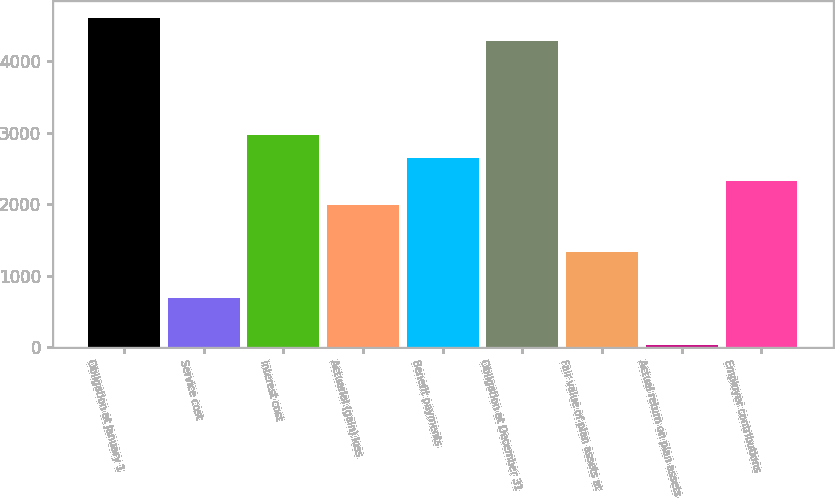Convert chart. <chart><loc_0><loc_0><loc_500><loc_500><bar_chart><fcel>Obligation at January 1<fcel>Service cost<fcel>Interest cost<fcel>Actuarial (gain) loss<fcel>Benefit payments<fcel>Obligation at December 31<fcel>Fair value of plan assets at<fcel>Actual return on plan assets<fcel>Employer contributions<nl><fcel>4608.6<fcel>679.8<fcel>2971.6<fcel>1989.4<fcel>2644.2<fcel>4281.2<fcel>1334.6<fcel>25<fcel>2316.8<nl></chart> 